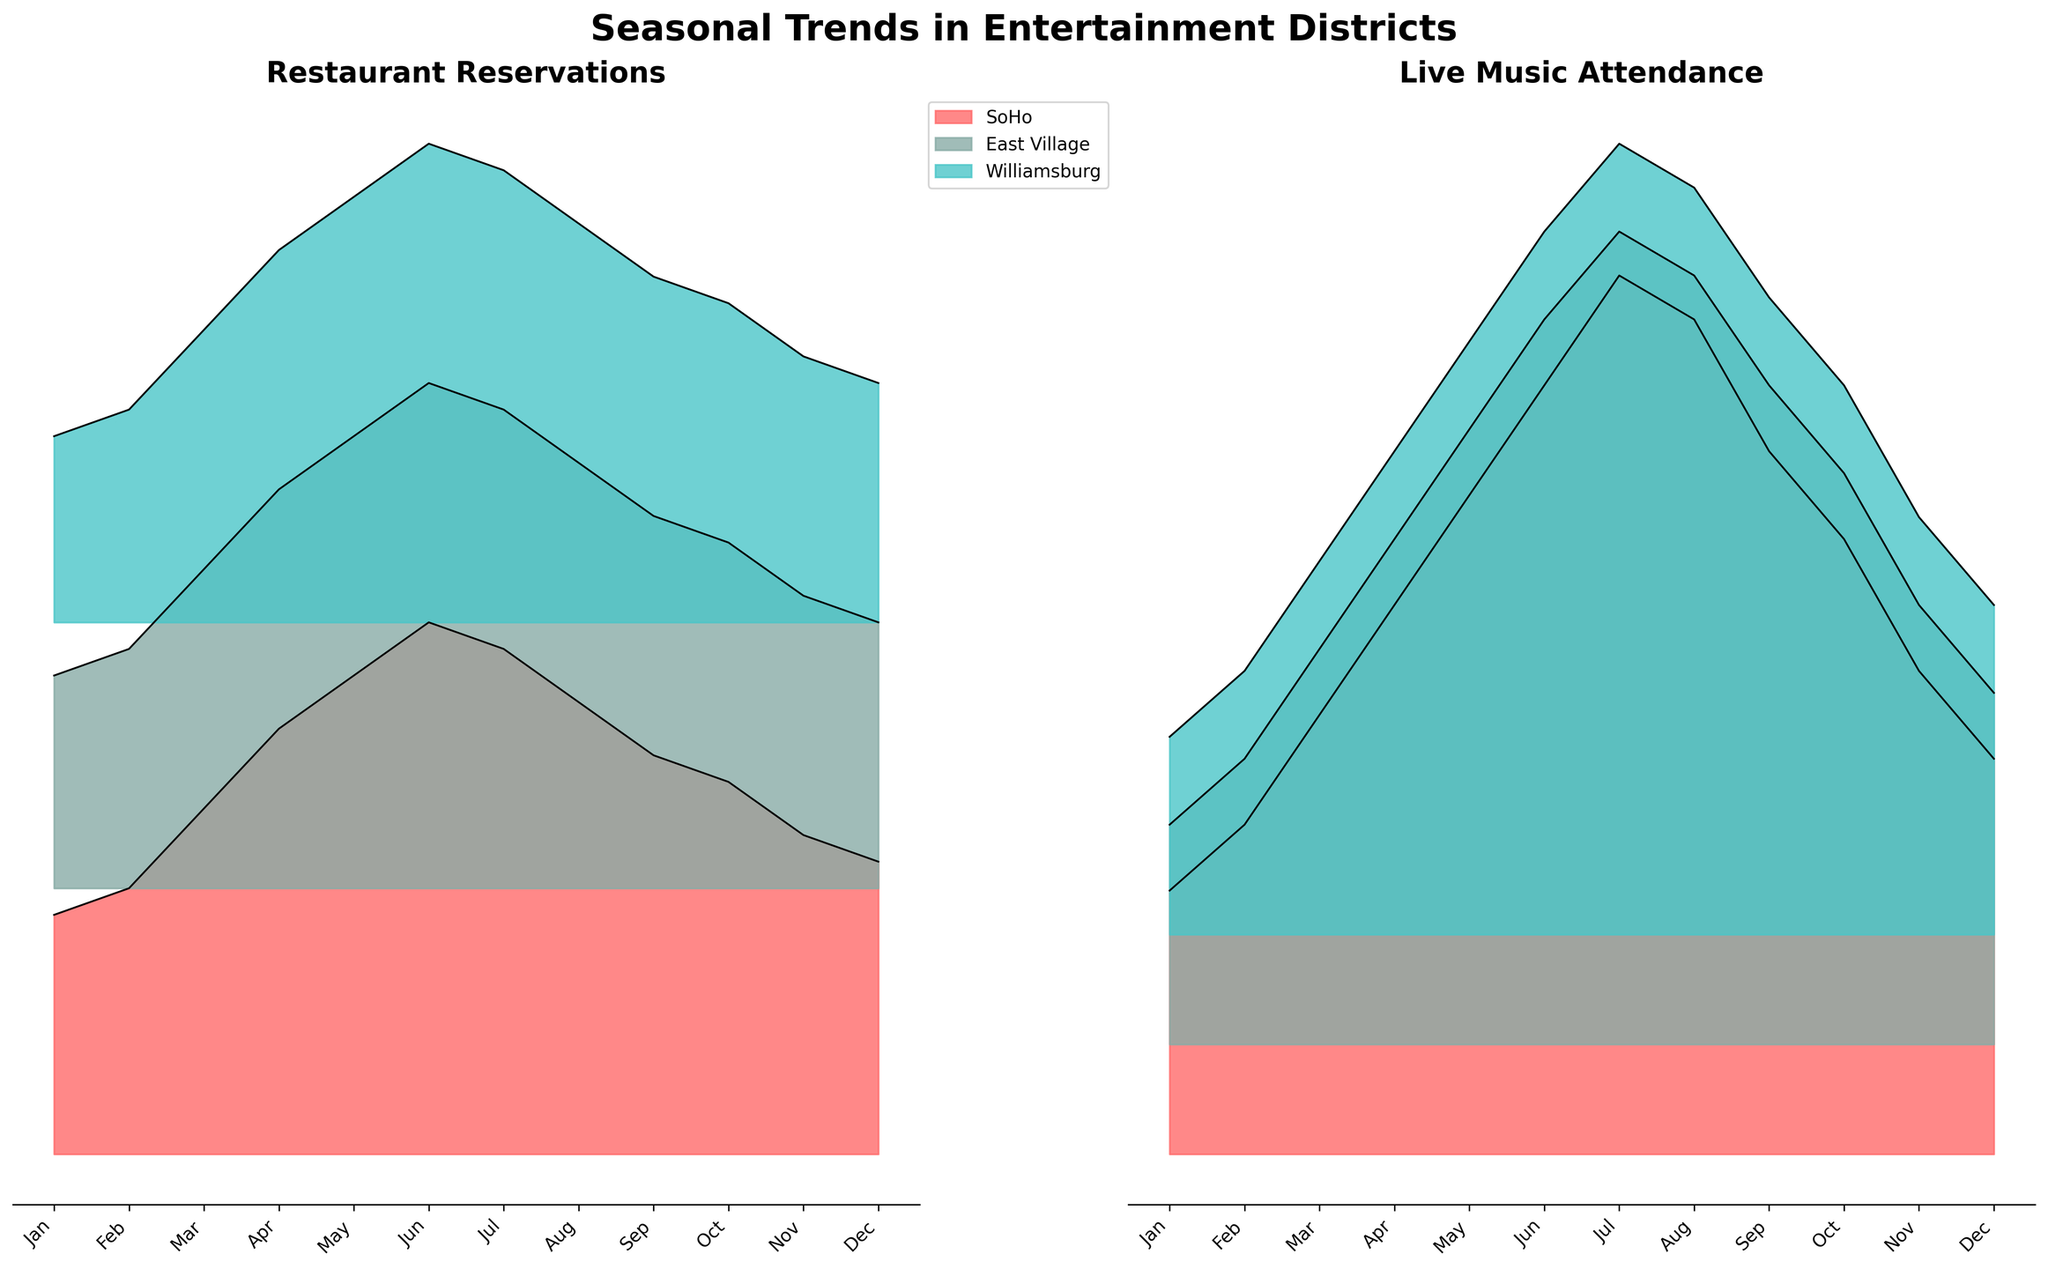Which district shows the highest number of restaurant reservations in July? First, locate the "Restaurant Reservations" plot. Next, find the July data point for each district and identify the highest value. Williamsburg is at 85, East Village is at 90, and SoHo is at 95. SoHo has the highest value.
Answer: SoHo In which month does live music attendance peak in East Village? Locate the "Live Music Attendance" plot specific to East Village. Trace the months to find the peak value. The highest attendance for East Village is in July with a count of 370.
Answer: July What is the difference in restaurant reservations between SoHo and East Village in March? Look at the "Restaurant Reservations" plot. Find the data point for March in both SoHo and East Village. SoHo has 65 reservations, and East Village has 60. Subtract 60 from 65 to get the difference.
Answer: 5 Which district has the least variation in live music attendance throughout the year? For each district in the "Live Music Attendance" plot, observe the range from minimum to maximum values. The ranges are SoHo (120 to 400), East Village (100 to 370), and Williamsburg (90 to 360). Williamsburg has the least range (270 units).
Answer: Williamsburg How does the trend of restaurant reservations compare between Williamsburg and SoHo from January to December? Observe the "Restaurant Reservations" plot for trends across months. Both Williamsburg and SoHo show an upward trend from January until summer, peaking around June/July, and then declining until December.
Answer: Similar trend During which month does Williamsburg have higher live music attendance than East Village? Compare the "Live Music Attendance" figures for Williamsburg and East Village month by month. For July, Williamsburg has 360, and East Village has 370. So you need to check the next highest month. For August, Williamsburg has 340 and East Village has 350, which again is lower. Check September, Williamsburg has 290 and East Village has 300. Check October, Williamsburg has 250, East Village has 260. For November, Williamsburg again is lower 190 than East Village (which has 200). Finally, in December, Williamsburg has 150 and East Village has 160. This pattern repeats for all other months, so there are no months where Williamsburg exceeds East Village.
Answer: None What is the average live music attendance in SoHo for the first quarter of the year? Identify the pro-portion of the year, Q1 (January, February, March). SoHo's live music attendance numbers are 120, 150, and 200, respectively for these months. Sum these values (120 + 150 + 200 = 470) and divide by 3.
Answer: 156.67 Which district has the highest overall peak in restaurant reservations, and in which month does this occur? Examine the peak points for each district in "Restaurant Reservations." SoHo has the highest peak at 100 in June. East Village peaks at 95 in June/July, and Williamsburg peaks at 90 in June.
Answer: SoHo, June 